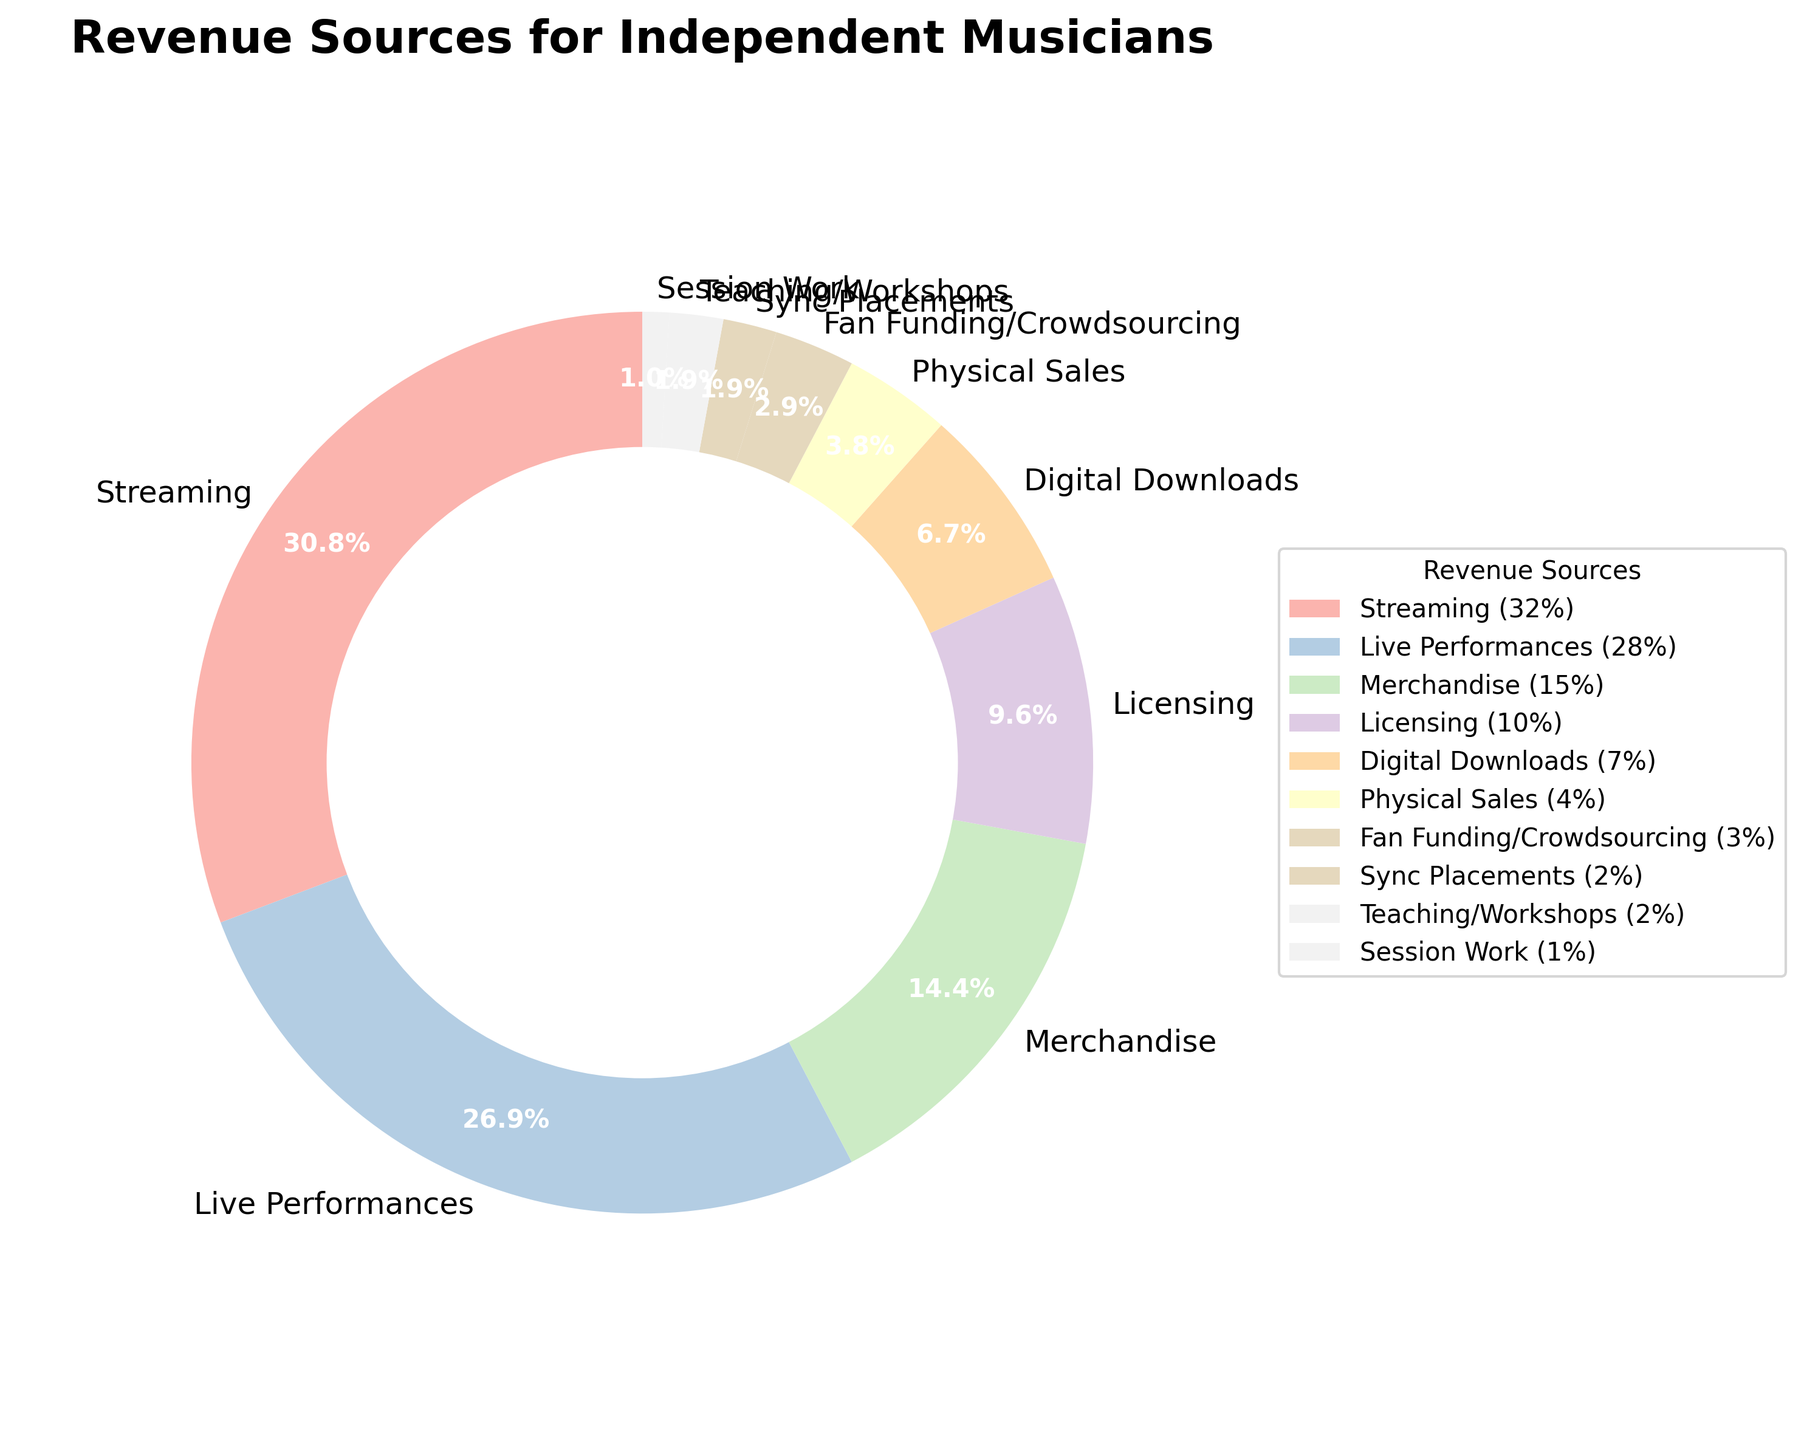what is the largest source of revenue for independent musicians? The largest section of the pie chart is labeled "Streaming" with 32%. Therefore, the largest source of revenue for independent musicians is streaming.
Answer: Streaming Which revenue source is smaller, live performances or merchandise? By comparing the pie chart sections for "Live Performances" (28%) and "Merchandise" (15%), we see that Merchandise is smaller than Live Performances.
Answer: Merchandise What percentage of revenue is generated by licensing and digital downloads combined? To find the combined percentage, we add the percentage of Licensing (10%) and Digital Downloads (7%). So, 10% + 7% = 17%.
Answer: 17% Is the revenue from teaching/workshops greater than the revenue from session work? The pie chart shows that Teaching/Workshops account for 2% while Session Work accounts for 1%. Therefore, Teaching/Workshops generate more revenue than Session Work.
Answer: Yes What percentage of revenue comes from activities other than streaming, live performances, and merchandise? First, sum the percentages for Streaming (32%), Live Performances (28%), and Merchandise (15%). This is 32% + 28% + 15% = 75%. Then, subtract this from 100% to find the remaining revenue: 100% - 75% = 25%.
Answer: 25% How much greater is the revenue from physical sales compared to sync placements? The chart shows Physical Sales at 4% and Sync Placements at 2%. The difference is 4% - 2% = 2%.
Answer: 2% If we group fan funding/crowdsourcing, sync placements, teaching/workshops, and session work together, what is their total percentage contribution? Adding percentages for Fan Funding/Crowdsourcing (3%), Sync Placements (2%), Teaching/Workshops (2%), and Session Work (1%) gives us 3% + 2% + 2% + 1% = 8%.
Answer: 8% Are there more revenue sources that contribute less than 5% or more than 5%? The pie chart has several sections: Fan Funding/Crowdsourcing (3%), Sync Placements (2%), Teaching/Workshops (2%), and Session Work (1%) contribute less than 5%. In total, 4 revenue sources contribute less than 5%. There are more revenue sources (6) that contribute more than 5%.
Answer: More than 5% 